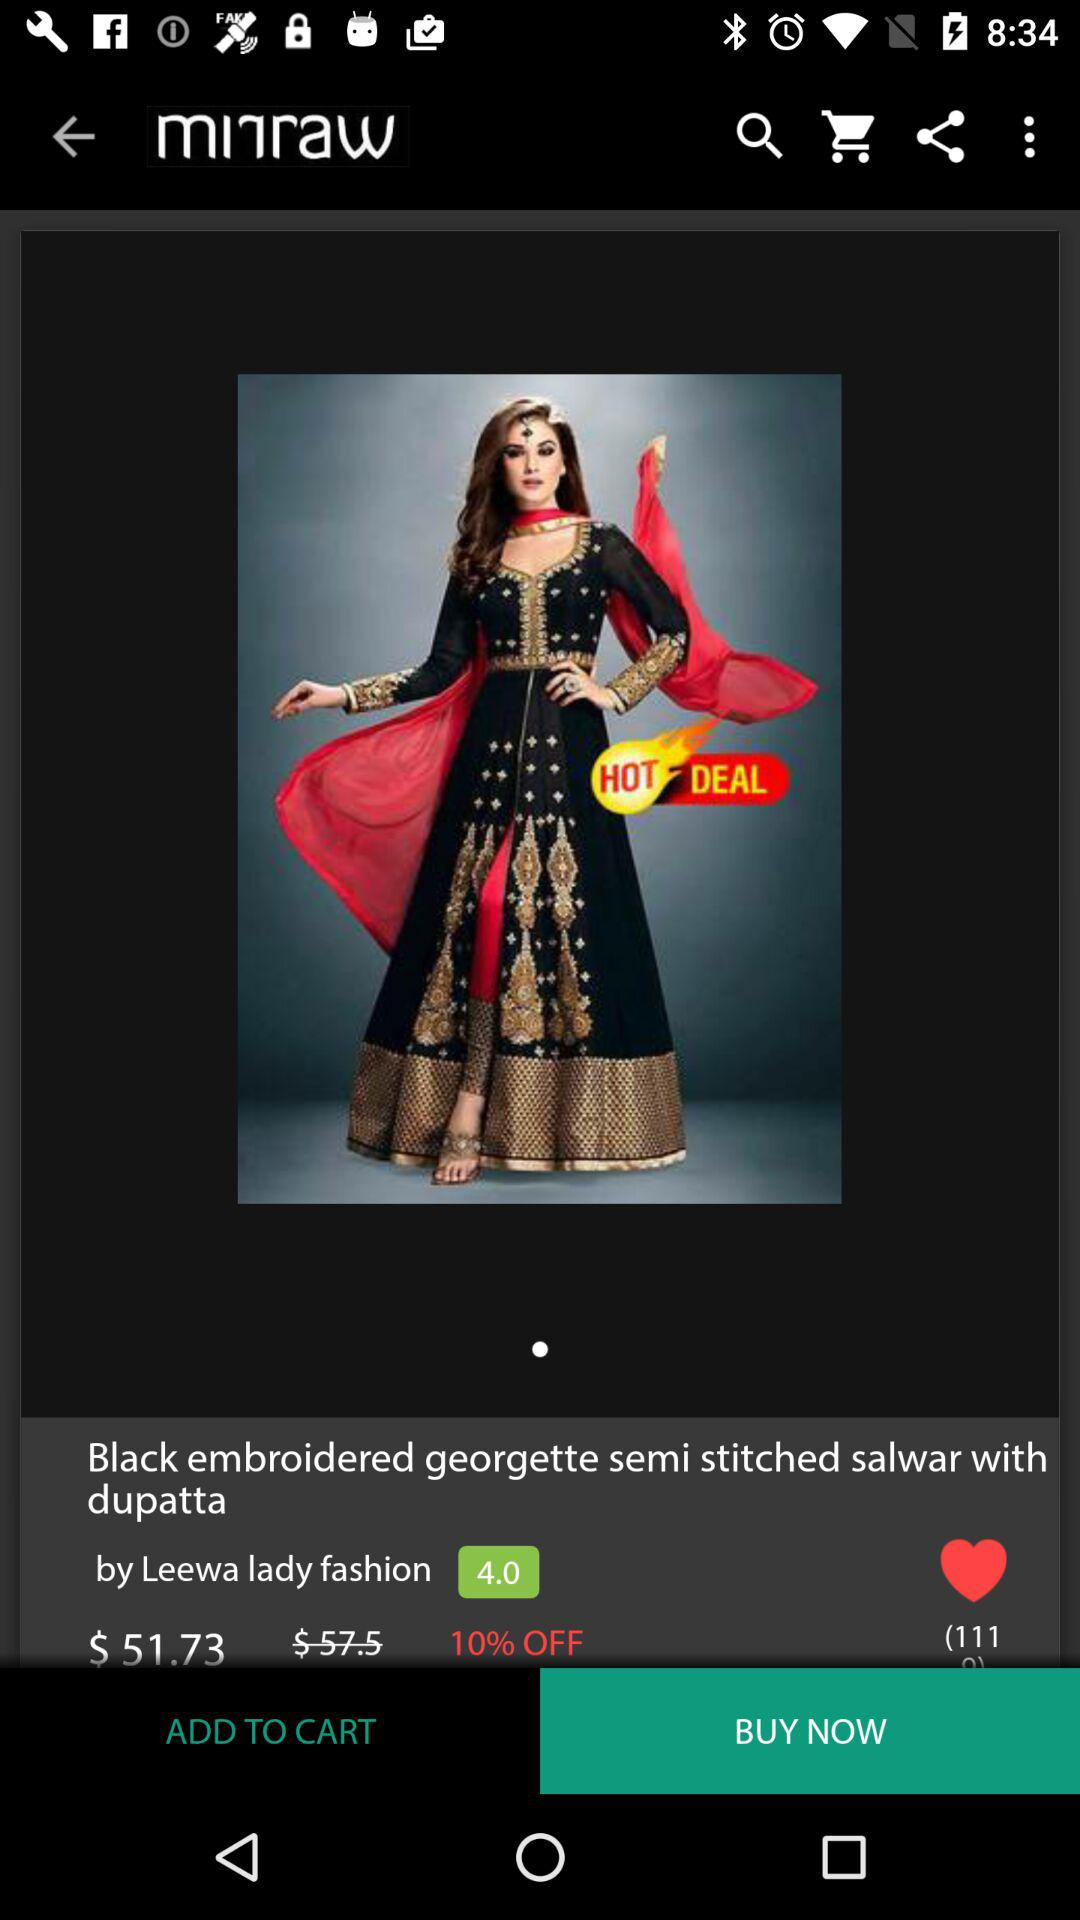How much is the discount?
Answer the question using a single word or phrase. 10% 